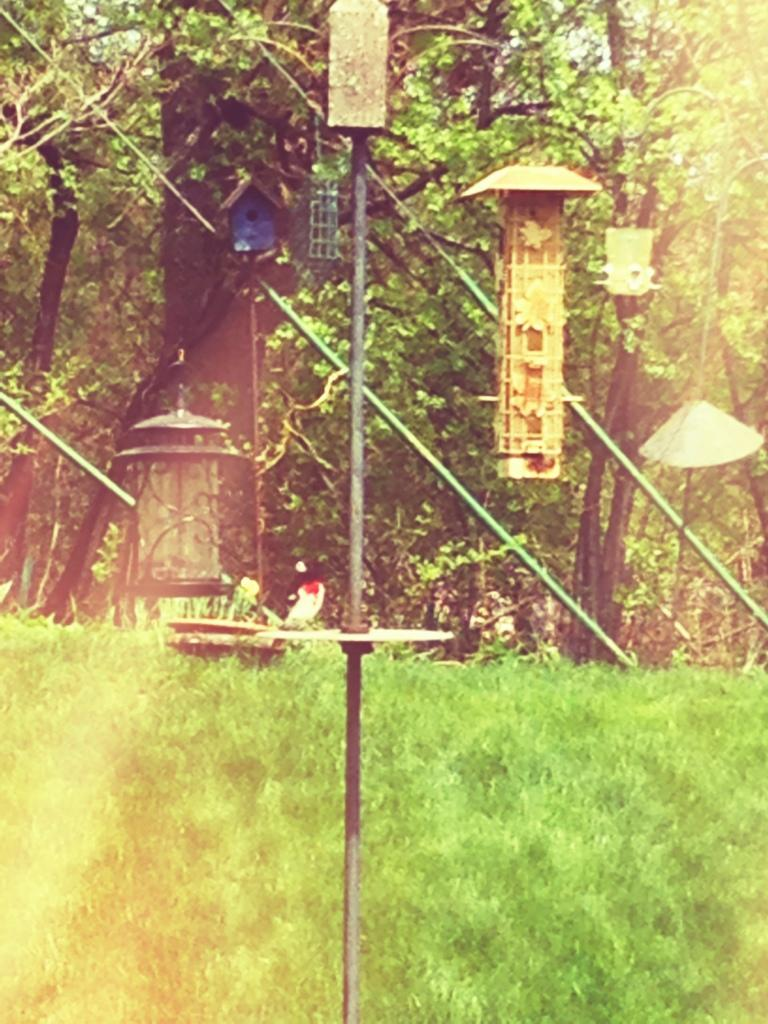What type of surface is on the ground in the image? There is grass on the ground in the image. What vertical structure can be seen in the image? There is a pole in the image. What type of material is used for the objects in the image? There are wooden objects in the image. What source of illumination is present in the image? There is a light in the image. What type of vegetation is visible in the image? There are trees in the image. Can you tell me how many people are swimming in the image? There is no swimming or people present in the image. What type of brass objects can be seen in the image? There is no brass or brass objects present in the image. 